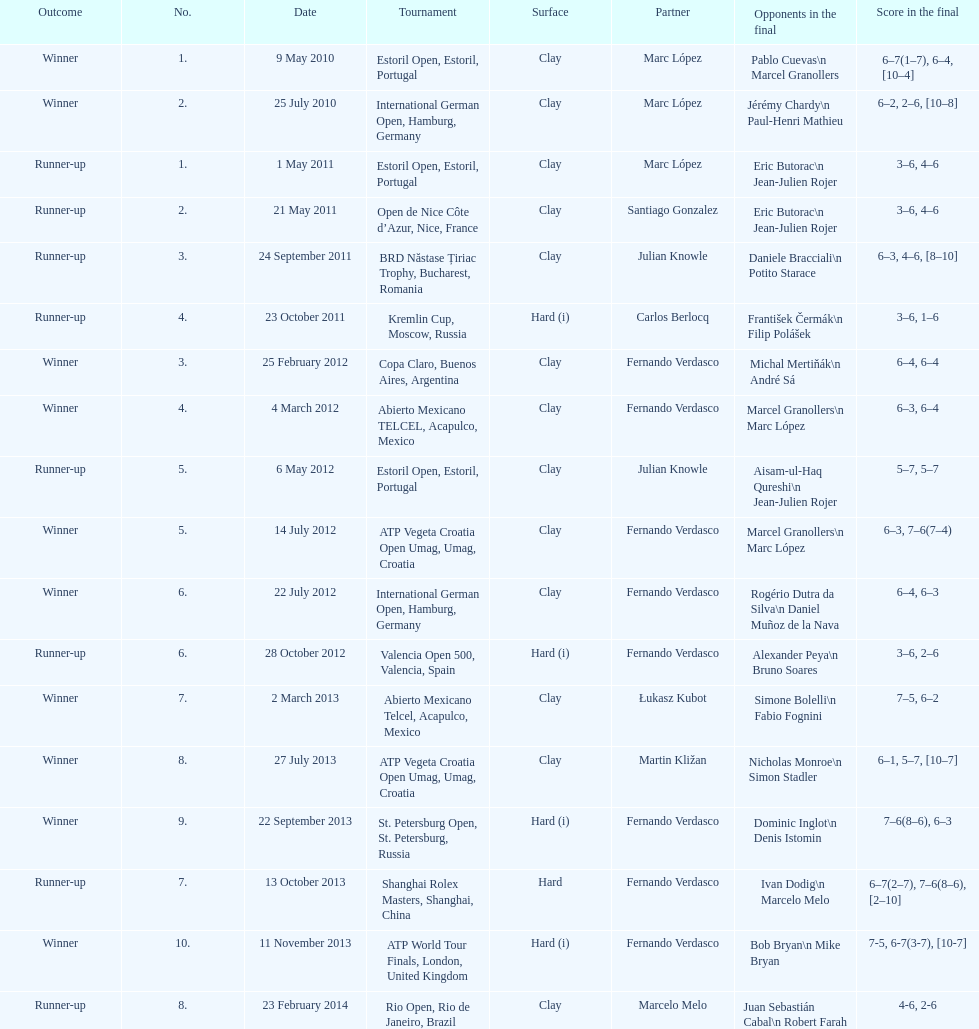What is the sum of runner-ups displayed on the chart? 8. 